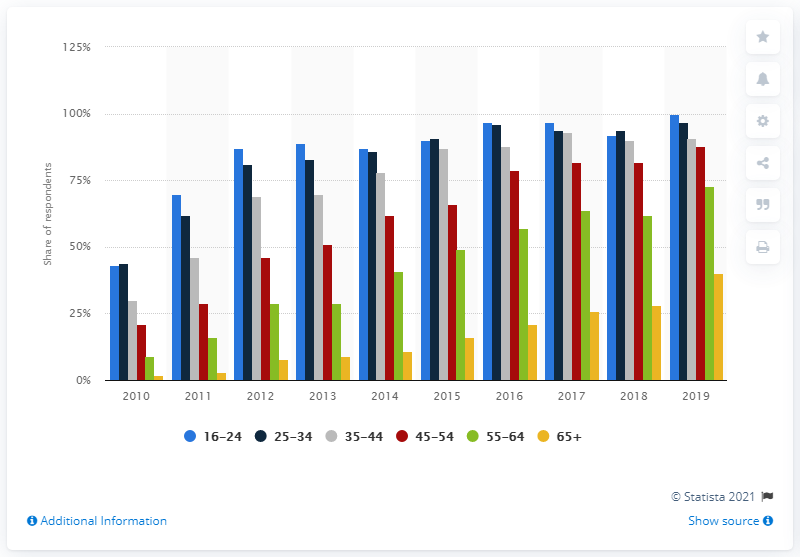Identify some key points in this picture. In 2019, 97% of 25-34 year olds used the internet. 